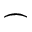Convert formula to latex. <formula><loc_0><loc_0><loc_500><loc_500>\frown</formula> 